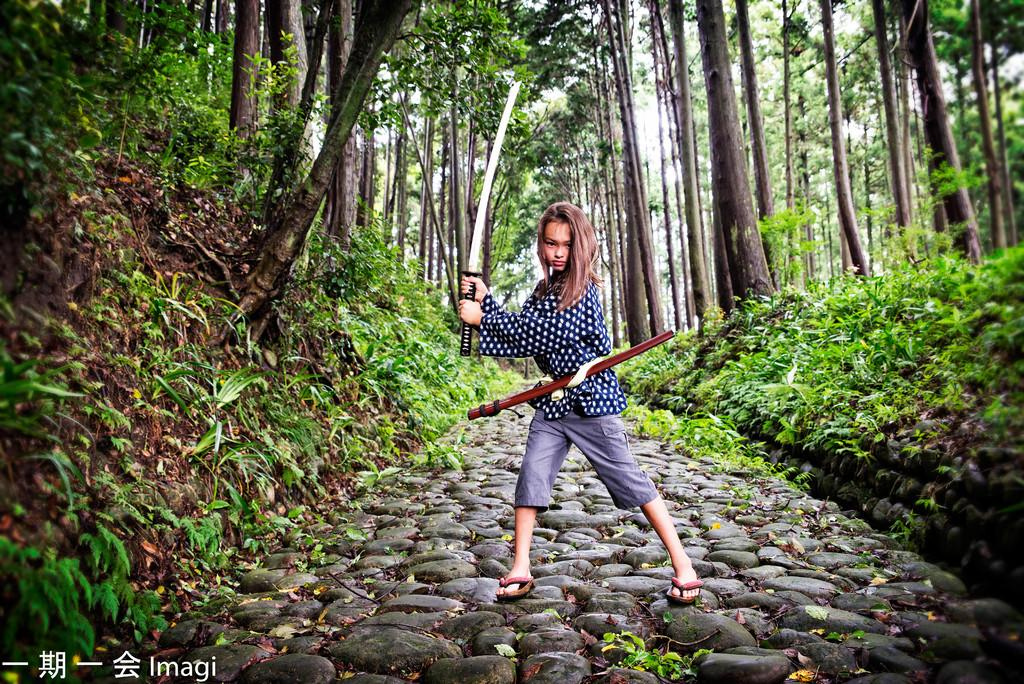What is the main subject of the image? There is a kid standing in the image. What is the kid holding in her hand? The kid is holding a sword in her hand. What can be seen in the background of the image? There are trees visible in the background of the image. What type of whip is the kid using to represent her country in the image? There is no whip present in the image, and the kid is not representing any country. 